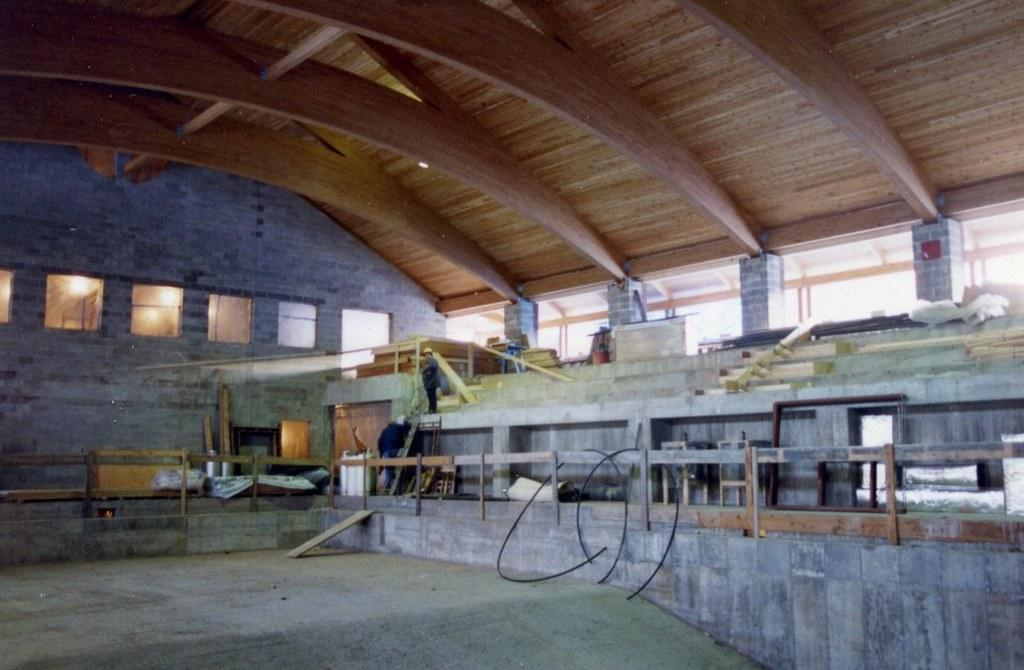What type of location is depicted in the image? The image is an inside view of a hall. What can be observed about the roof of the hall? There is a wooden roof in the hall. Are there any other objects or features in the hall besides the roof? Yes, there are other items in the hall. Can you describe the presence of any people in the image? There is a person standing in the hall. What type of fruit is the person holding in the image? There is no fruit visible in the image, and the person standing in the hall is not holding any fruit. Can you describe the person's trousers in the image? The facts provided do not mention the person's trousers, so we cannot describe them. 